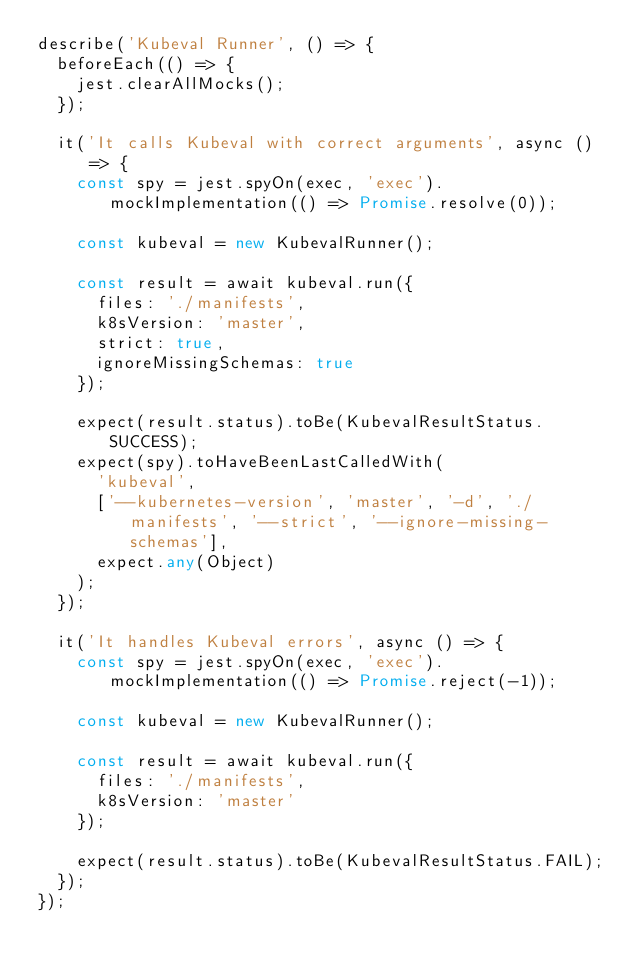<code> <loc_0><loc_0><loc_500><loc_500><_TypeScript_>describe('Kubeval Runner', () => {
  beforeEach(() => {
    jest.clearAllMocks();
  });

  it('It calls Kubeval with correct arguments', async () => {
    const spy = jest.spyOn(exec, 'exec').mockImplementation(() => Promise.resolve(0));

    const kubeval = new KubevalRunner();

    const result = await kubeval.run({
      files: './manifests',
      k8sVersion: 'master',
      strict: true,
      ignoreMissingSchemas: true
    });

    expect(result.status).toBe(KubevalResultStatus.SUCCESS);
    expect(spy).toHaveBeenLastCalledWith(
      'kubeval',
      ['--kubernetes-version', 'master', '-d', './manifests', '--strict', '--ignore-missing-schemas'],
      expect.any(Object)
    );
  });

  it('It handles Kubeval errors', async () => {
    const spy = jest.spyOn(exec, 'exec').mockImplementation(() => Promise.reject(-1));

    const kubeval = new KubevalRunner();

    const result = await kubeval.run({
      files: './manifests',
      k8sVersion: 'master'
    });

    expect(result.status).toBe(KubevalResultStatus.FAIL);
  });
});
</code> 